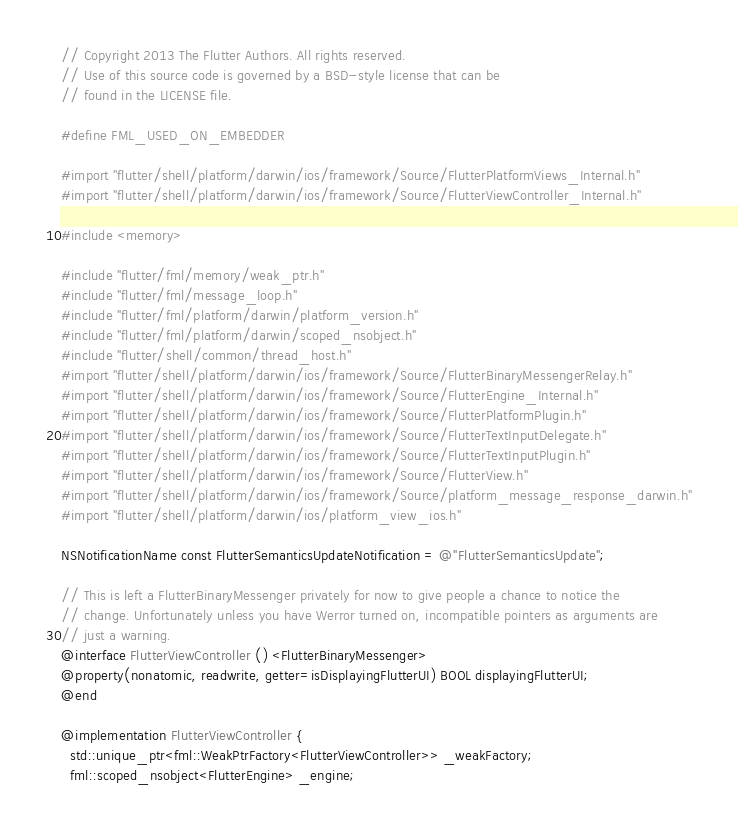Convert code to text. <code><loc_0><loc_0><loc_500><loc_500><_ObjectiveC_>// Copyright 2013 The Flutter Authors. All rights reserved.
// Use of this source code is governed by a BSD-style license that can be
// found in the LICENSE file.

#define FML_USED_ON_EMBEDDER

#import "flutter/shell/platform/darwin/ios/framework/Source/FlutterPlatformViews_Internal.h"
#import "flutter/shell/platform/darwin/ios/framework/Source/FlutterViewController_Internal.h"

#include <memory>

#include "flutter/fml/memory/weak_ptr.h"
#include "flutter/fml/message_loop.h"
#include "flutter/fml/platform/darwin/platform_version.h"
#include "flutter/fml/platform/darwin/scoped_nsobject.h"
#include "flutter/shell/common/thread_host.h"
#import "flutter/shell/platform/darwin/ios/framework/Source/FlutterBinaryMessengerRelay.h"
#import "flutter/shell/platform/darwin/ios/framework/Source/FlutterEngine_Internal.h"
#import "flutter/shell/platform/darwin/ios/framework/Source/FlutterPlatformPlugin.h"
#import "flutter/shell/platform/darwin/ios/framework/Source/FlutterTextInputDelegate.h"
#import "flutter/shell/platform/darwin/ios/framework/Source/FlutterTextInputPlugin.h"
#import "flutter/shell/platform/darwin/ios/framework/Source/FlutterView.h"
#import "flutter/shell/platform/darwin/ios/framework/Source/platform_message_response_darwin.h"
#import "flutter/shell/platform/darwin/ios/platform_view_ios.h"

NSNotificationName const FlutterSemanticsUpdateNotification = @"FlutterSemanticsUpdate";

// This is left a FlutterBinaryMessenger privately for now to give people a chance to notice the
// change. Unfortunately unless you have Werror turned on, incompatible pointers as arguments are
// just a warning.
@interface FlutterViewController () <FlutterBinaryMessenger>
@property(nonatomic, readwrite, getter=isDisplayingFlutterUI) BOOL displayingFlutterUI;
@end

@implementation FlutterViewController {
  std::unique_ptr<fml::WeakPtrFactory<FlutterViewController>> _weakFactory;
  fml::scoped_nsobject<FlutterEngine> _engine;
</code> 